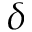<formula> <loc_0><loc_0><loc_500><loc_500>\delta</formula> 